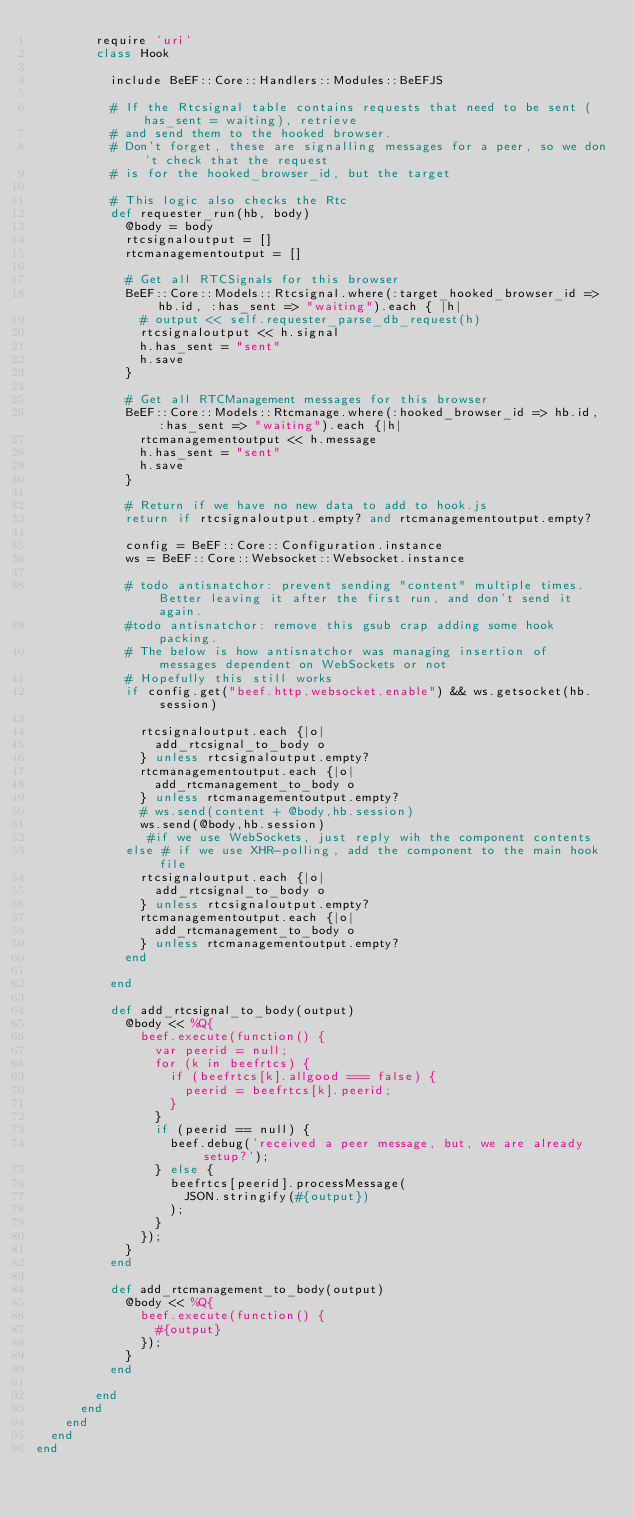<code> <loc_0><loc_0><loc_500><loc_500><_Ruby_>        require 'uri'
        class Hook

          include BeEF::Core::Handlers::Modules::BeEFJS

          # If the Rtcsignal table contains requests that need to be sent (has_sent = waiting), retrieve
          # and send them to the hooked browser.
          # Don't forget, these are signalling messages for a peer, so we don't check that the request
          # is for the hooked_browser_id, but the target

          # This logic also checks the Rtc
          def requester_run(hb, body)
            @body = body
            rtcsignaloutput = []
            rtcmanagementoutput = []

            # Get all RTCSignals for this browser
            BeEF::Core::Models::Rtcsignal.where(:target_hooked_browser_id => hb.id, :has_sent => "waiting").each { |h|
              # output << self.requester_parse_db_request(h)
              rtcsignaloutput << h.signal
              h.has_sent = "sent"
              h.save
            }

            # Get all RTCManagement messages for this browser
            BeEF::Core::Models::Rtcmanage.where(:hooked_browser_id => hb.id, :has_sent => "waiting").each {|h|
              rtcmanagementoutput << h.message
              h.has_sent = "sent"
              h.save
            }

            # Return if we have no new data to add to hook.js
            return if rtcsignaloutput.empty? and rtcmanagementoutput.empty?

            config = BeEF::Core::Configuration.instance
            ws = BeEF::Core::Websocket::Websocket.instance

            # todo antisnatchor: prevent sending "content" multiple times. Better leaving it after the first run, and don't send it again.
            #todo antisnatchor: remove this gsub crap adding some hook packing.
            # The below is how antisnatchor was managing insertion of messages dependent on WebSockets or not
            # Hopefully this still works
            if config.get("beef.http.websocket.enable") && ws.getsocket(hb.session)
              
              rtcsignaloutput.each {|o|
                add_rtcsignal_to_body o
              } unless rtcsignaloutput.empty?
              rtcmanagementoutput.each {|o|
                add_rtcmanagement_to_body o
              } unless rtcmanagementoutput.empty?
              # ws.send(content + @body,hb.session)
              ws.send(@body,hb.session)
               #if we use WebSockets, just reply wih the component contents
            else # if we use XHR-polling, add the component to the main hook file
              rtcsignaloutput.each {|o|
                add_rtcsignal_to_body o
              } unless rtcsignaloutput.empty?
              rtcmanagementoutput.each {|o|
                add_rtcmanagement_to_body o
              } unless rtcmanagementoutput.empty?
            end

          end

          def add_rtcsignal_to_body(output)
            @body << %Q{
              beef.execute(function() {
                var peerid = null;
                for (k in beefrtcs) {
                  if (beefrtcs[k].allgood === false) {
                    peerid = beefrtcs[k].peerid;
                  }
                }
                if (peerid == null) {
                  beef.debug('received a peer message, but, we are already setup?');
                } else {
                  beefrtcs[peerid].processMessage(
                    JSON.stringify(#{output})
                  );
                }
              });
            }
          end

          def add_rtcmanagement_to_body(output)
            @body << %Q{
              beef.execute(function() {
                #{output}
              });
            }
          end

        end
      end
    end
  end
end
</code> 